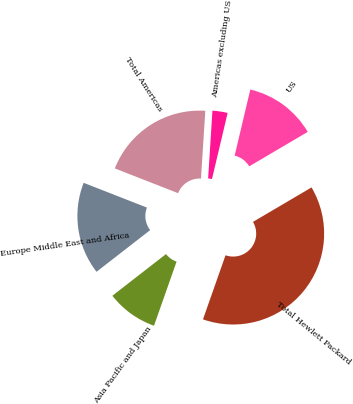Convert chart. <chart><loc_0><loc_0><loc_500><loc_500><pie_chart><fcel>US<fcel>Americas excluding US<fcel>Total Americas<fcel>Europe Middle East and Africa<fcel>Asia Pacific and Japan<fcel>Total Hewlett Packard<nl><fcel>12.83%<fcel>2.69%<fcel>20.07%<fcel>16.45%<fcel>9.1%<fcel>38.85%<nl></chart> 